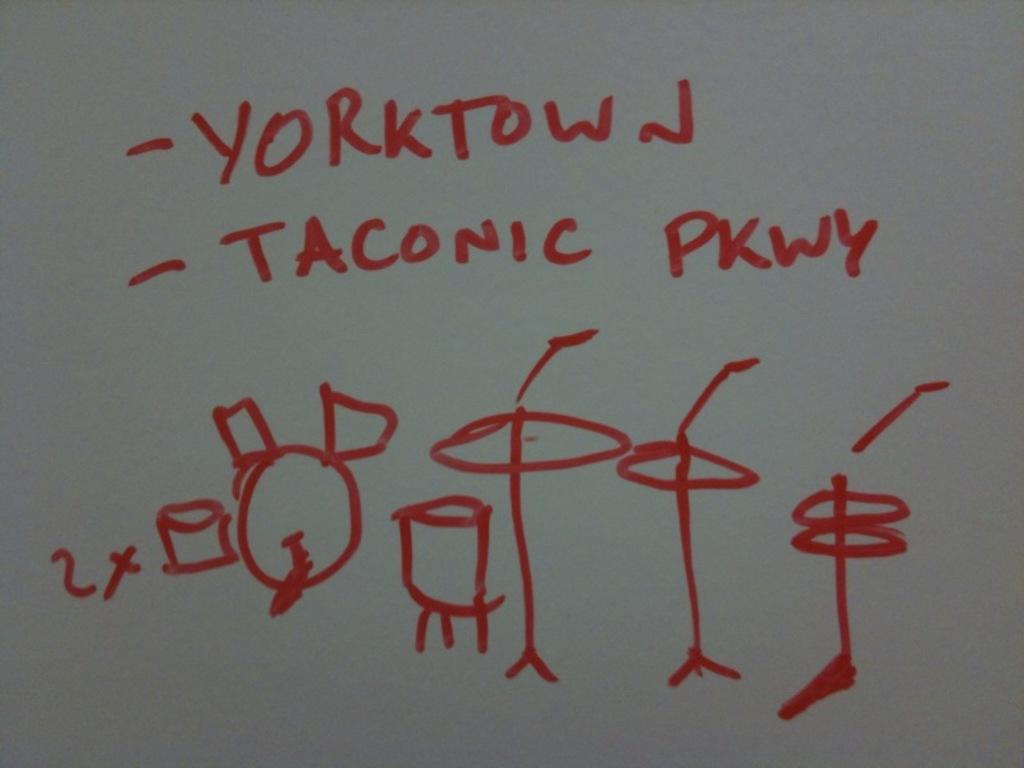<image>
Offer a succinct explanation of the picture presented. A stick figure drawing in red marker says "yorktown". 